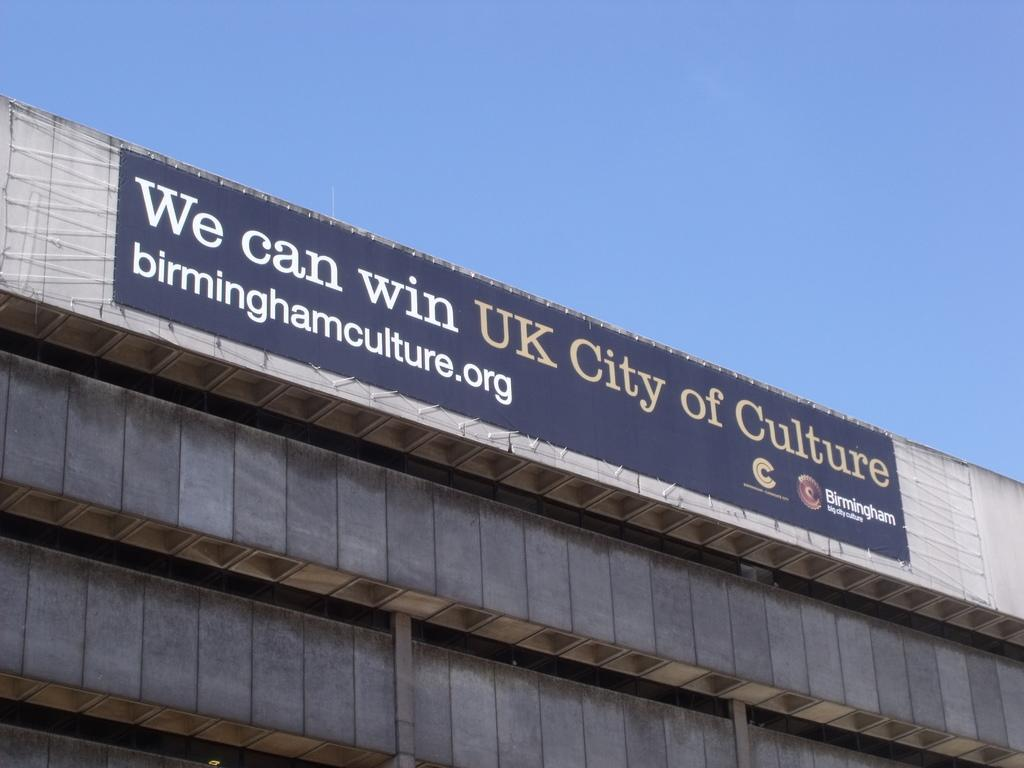What is hanging on the wall in the image? There is a banner on the wall in the image. What type of structure is at the bottom of the image? There is a building at the bottom of the image. What can be seen in the sky in the image? The sky is visible at the top of the image. How many forks are visible in the image? There are no forks present in the image. What type of fan is hanging from the ceiling in the image? There is no fan present in the image. 